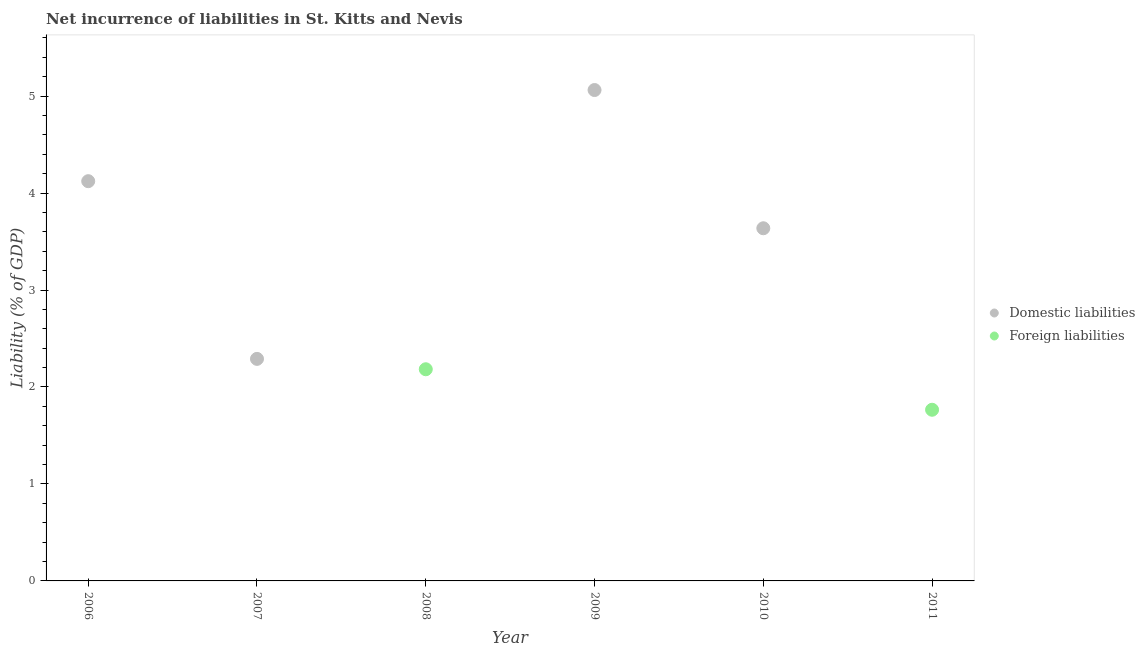How many different coloured dotlines are there?
Offer a very short reply. 2. Across all years, what is the maximum incurrence of domestic liabilities?
Make the answer very short. 5.06. What is the total incurrence of foreign liabilities in the graph?
Provide a succinct answer. 3.95. What is the difference between the incurrence of domestic liabilities in 2006 and that in 2009?
Provide a short and direct response. -0.94. What is the difference between the incurrence of foreign liabilities in 2007 and the incurrence of domestic liabilities in 2008?
Your response must be concise. 0. What is the average incurrence of domestic liabilities per year?
Your answer should be very brief. 2.52. What is the ratio of the incurrence of foreign liabilities in 2008 to that in 2011?
Offer a terse response. 1.24. What is the difference between the highest and the second highest incurrence of domestic liabilities?
Your answer should be very brief. 0.94. What is the difference between the highest and the lowest incurrence of foreign liabilities?
Offer a very short reply. 2.18. Is the incurrence of foreign liabilities strictly less than the incurrence of domestic liabilities over the years?
Provide a succinct answer. No. How many dotlines are there?
Offer a very short reply. 2. How many years are there in the graph?
Ensure brevity in your answer.  6. What is the difference between two consecutive major ticks on the Y-axis?
Your answer should be compact. 1. Are the values on the major ticks of Y-axis written in scientific E-notation?
Make the answer very short. No. How many legend labels are there?
Your answer should be compact. 2. What is the title of the graph?
Make the answer very short. Net incurrence of liabilities in St. Kitts and Nevis. Does "From production" appear as one of the legend labels in the graph?
Your answer should be very brief. No. What is the label or title of the Y-axis?
Provide a short and direct response. Liability (% of GDP). What is the Liability (% of GDP) of Domestic liabilities in 2006?
Your answer should be compact. 4.12. What is the Liability (% of GDP) of Domestic liabilities in 2007?
Make the answer very short. 2.29. What is the Liability (% of GDP) in Foreign liabilities in 2007?
Provide a succinct answer. 0. What is the Liability (% of GDP) in Domestic liabilities in 2008?
Ensure brevity in your answer.  0. What is the Liability (% of GDP) of Foreign liabilities in 2008?
Give a very brief answer. 2.18. What is the Liability (% of GDP) of Domestic liabilities in 2009?
Your response must be concise. 5.06. What is the Liability (% of GDP) of Foreign liabilities in 2009?
Your answer should be very brief. 0. What is the Liability (% of GDP) in Domestic liabilities in 2010?
Offer a very short reply. 3.64. What is the Liability (% of GDP) in Domestic liabilities in 2011?
Offer a very short reply. 0. What is the Liability (% of GDP) in Foreign liabilities in 2011?
Your answer should be very brief. 1.77. Across all years, what is the maximum Liability (% of GDP) in Domestic liabilities?
Provide a succinct answer. 5.06. Across all years, what is the maximum Liability (% of GDP) of Foreign liabilities?
Provide a short and direct response. 2.18. Across all years, what is the minimum Liability (% of GDP) of Domestic liabilities?
Keep it short and to the point. 0. Across all years, what is the minimum Liability (% of GDP) in Foreign liabilities?
Your answer should be compact. 0. What is the total Liability (% of GDP) in Domestic liabilities in the graph?
Keep it short and to the point. 15.11. What is the total Liability (% of GDP) of Foreign liabilities in the graph?
Offer a terse response. 3.95. What is the difference between the Liability (% of GDP) in Domestic liabilities in 2006 and that in 2007?
Make the answer very short. 1.83. What is the difference between the Liability (% of GDP) in Domestic liabilities in 2006 and that in 2009?
Your answer should be compact. -0.94. What is the difference between the Liability (% of GDP) in Domestic liabilities in 2006 and that in 2010?
Provide a succinct answer. 0.49. What is the difference between the Liability (% of GDP) in Domestic liabilities in 2007 and that in 2009?
Your answer should be very brief. -2.77. What is the difference between the Liability (% of GDP) in Domestic liabilities in 2007 and that in 2010?
Make the answer very short. -1.35. What is the difference between the Liability (% of GDP) in Foreign liabilities in 2008 and that in 2011?
Your response must be concise. 0.42. What is the difference between the Liability (% of GDP) of Domestic liabilities in 2009 and that in 2010?
Provide a succinct answer. 1.43. What is the difference between the Liability (% of GDP) in Domestic liabilities in 2006 and the Liability (% of GDP) in Foreign liabilities in 2008?
Offer a very short reply. 1.94. What is the difference between the Liability (% of GDP) in Domestic liabilities in 2006 and the Liability (% of GDP) in Foreign liabilities in 2011?
Your answer should be compact. 2.36. What is the difference between the Liability (% of GDP) in Domestic liabilities in 2007 and the Liability (% of GDP) in Foreign liabilities in 2008?
Keep it short and to the point. 0.11. What is the difference between the Liability (% of GDP) of Domestic liabilities in 2007 and the Liability (% of GDP) of Foreign liabilities in 2011?
Offer a very short reply. 0.52. What is the difference between the Liability (% of GDP) of Domestic liabilities in 2009 and the Liability (% of GDP) of Foreign liabilities in 2011?
Make the answer very short. 3.3. What is the difference between the Liability (% of GDP) in Domestic liabilities in 2010 and the Liability (% of GDP) in Foreign liabilities in 2011?
Your answer should be very brief. 1.87. What is the average Liability (% of GDP) in Domestic liabilities per year?
Ensure brevity in your answer.  2.52. What is the average Liability (% of GDP) of Foreign liabilities per year?
Offer a very short reply. 0.66. What is the ratio of the Liability (% of GDP) of Domestic liabilities in 2006 to that in 2007?
Your answer should be very brief. 1.8. What is the ratio of the Liability (% of GDP) in Domestic liabilities in 2006 to that in 2009?
Your response must be concise. 0.81. What is the ratio of the Liability (% of GDP) in Domestic liabilities in 2006 to that in 2010?
Ensure brevity in your answer.  1.13. What is the ratio of the Liability (% of GDP) of Domestic liabilities in 2007 to that in 2009?
Keep it short and to the point. 0.45. What is the ratio of the Liability (% of GDP) in Domestic liabilities in 2007 to that in 2010?
Make the answer very short. 0.63. What is the ratio of the Liability (% of GDP) in Foreign liabilities in 2008 to that in 2011?
Offer a very short reply. 1.24. What is the ratio of the Liability (% of GDP) in Domestic liabilities in 2009 to that in 2010?
Provide a short and direct response. 1.39. What is the difference between the highest and the second highest Liability (% of GDP) of Domestic liabilities?
Make the answer very short. 0.94. What is the difference between the highest and the lowest Liability (% of GDP) in Domestic liabilities?
Your answer should be very brief. 5.06. What is the difference between the highest and the lowest Liability (% of GDP) in Foreign liabilities?
Your answer should be very brief. 2.18. 